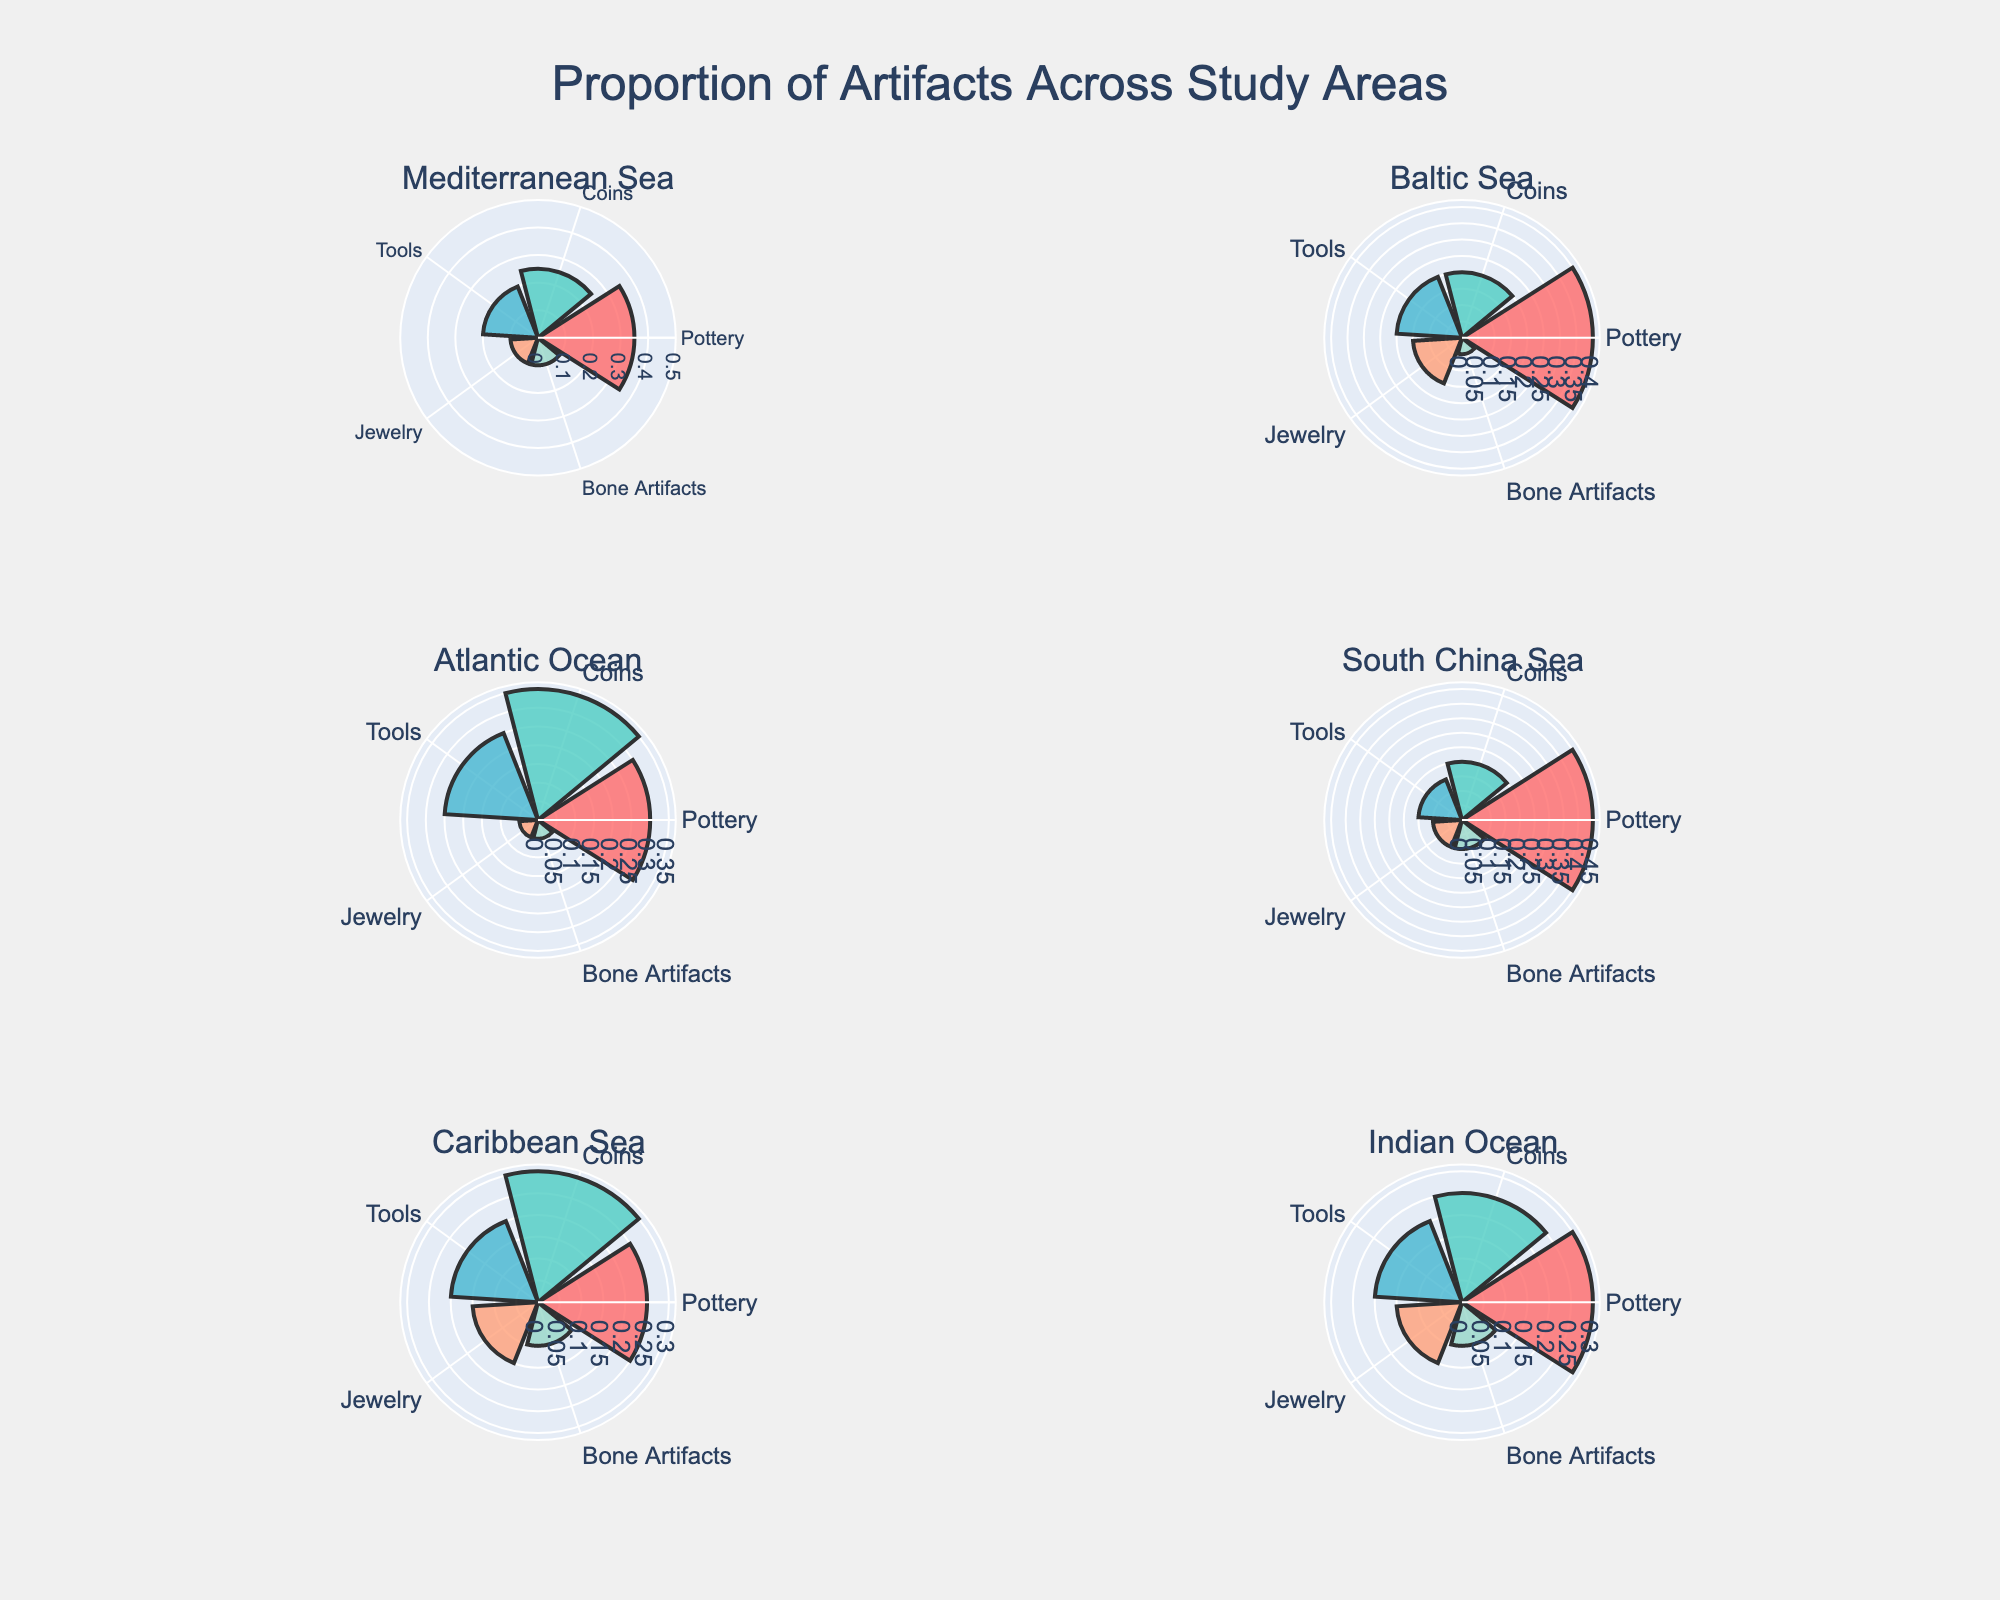What is the title of the figure? The title is prominently displayed at the top of the figure. It summarizes the main theme of the visualization.
Answer: Proportion of Artifacts Across Study Areas Which study area has the highest proportion of coins discovered? By observing the segments in the rose charts, the study area with the largest segment for coins can be identified.
Answer: Atlantic Ocean What is the combined proportion of tools and jewelry discovered in the Baltic Sea? Sum the proportions of tools and jewelry in the Baltic Sea: 0.20 (tools) + 0.15 (jewelry) = 0.35.
Answer: 0.35 How does the proportion of pottery in the South China Sea compare to the Mediterranean Sea? Compare the proportions of pottery between the two areas: South China Sea (0.45) is greater than Mediterranean Sea (0.35).
Answer: South China Sea > Mediterranean Sea Which artifact type has the lowest proportion in the Caribbean Sea? Identify the smallest segment in the Caribbean Sea rose chart.
Answer: Bone Artifacts In which study area is the proportion of bone artifacts exactly the same as in the Mediterranean Sea? Look for study areas where bone artifacts have the same proportion as in the Mediterranean Sea (0.10).
Answer: South China Sea and Caribbean Sea What is the average proportion of coins discovered across all study areas? Sum the proportions of coins and divide by the number of study areas: (0.25 + 0.20 + 0.35 + 0.20 + 0.30 + 0.25) / 6 = 1.55 / 6 = 0.2583.
Answer: 0.2583 How many different artifact types are represented in each rose chart? Count the number of distinct artifact types (Pottery, Coins, Tools, Jewelry, Bone Artifacts) in any rose chart.
Answer: 5 Which study area has the smallest proportion of jewelry discovered? Identify the study area with the smallest segment for jewelry.
Answer: Atlantic Ocean 